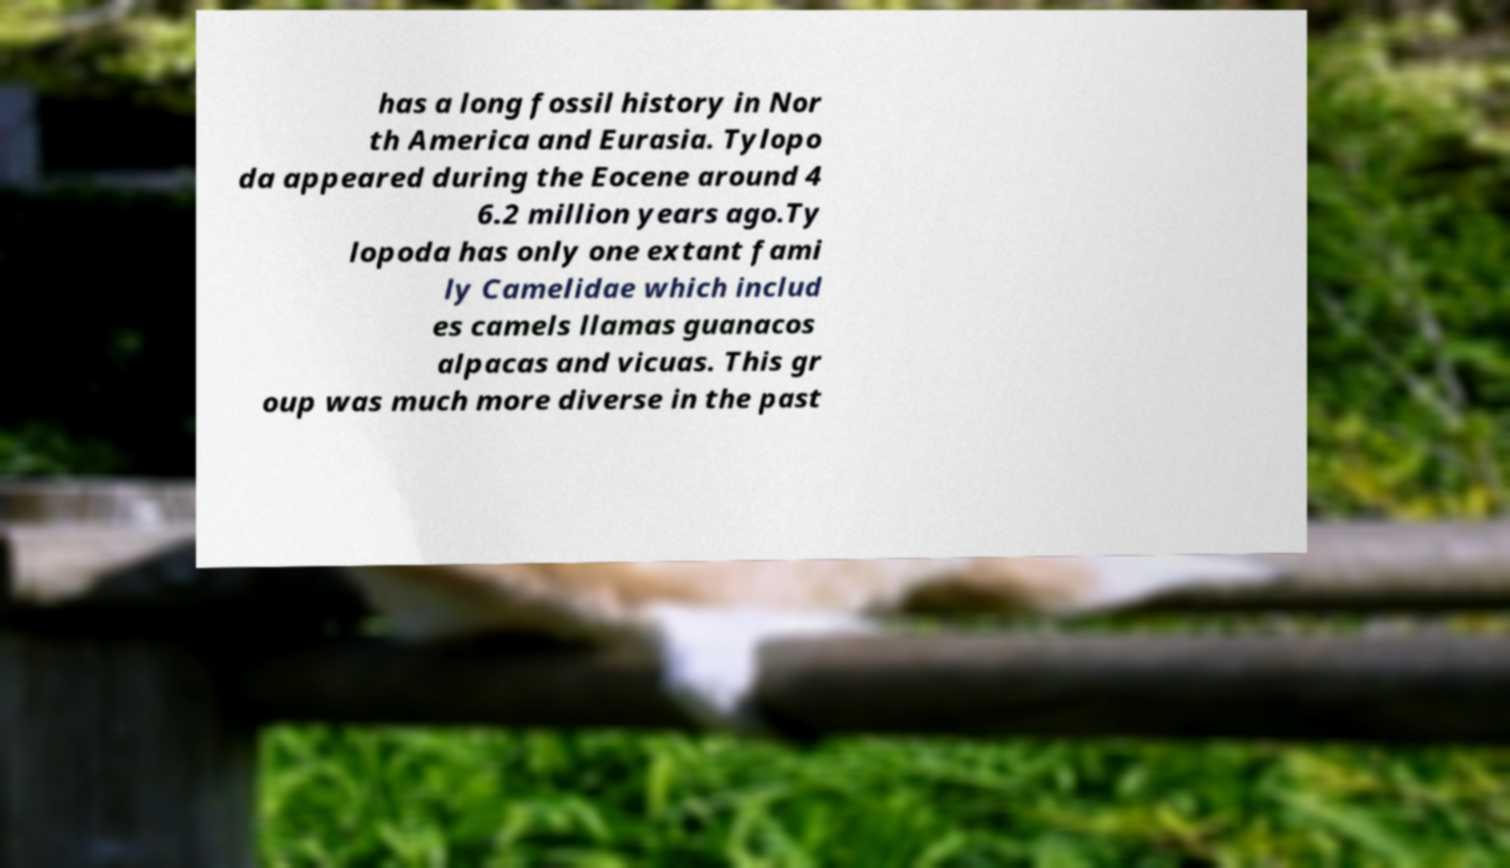Could you extract and type out the text from this image? has a long fossil history in Nor th America and Eurasia. Tylopo da appeared during the Eocene around 4 6.2 million years ago.Ty lopoda has only one extant fami ly Camelidae which includ es camels llamas guanacos alpacas and vicuas. This gr oup was much more diverse in the past 